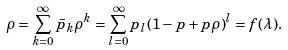Convert formula to latex. <formula><loc_0><loc_0><loc_500><loc_500>\rho = \sum _ { k = 0 } ^ { \infty } \bar { p } _ { k } \rho ^ { k } = \sum _ { l = 0 } ^ { \infty } p _ { l } ( 1 - p + p \rho ) ^ { l } = f ( \lambda ) .</formula> 